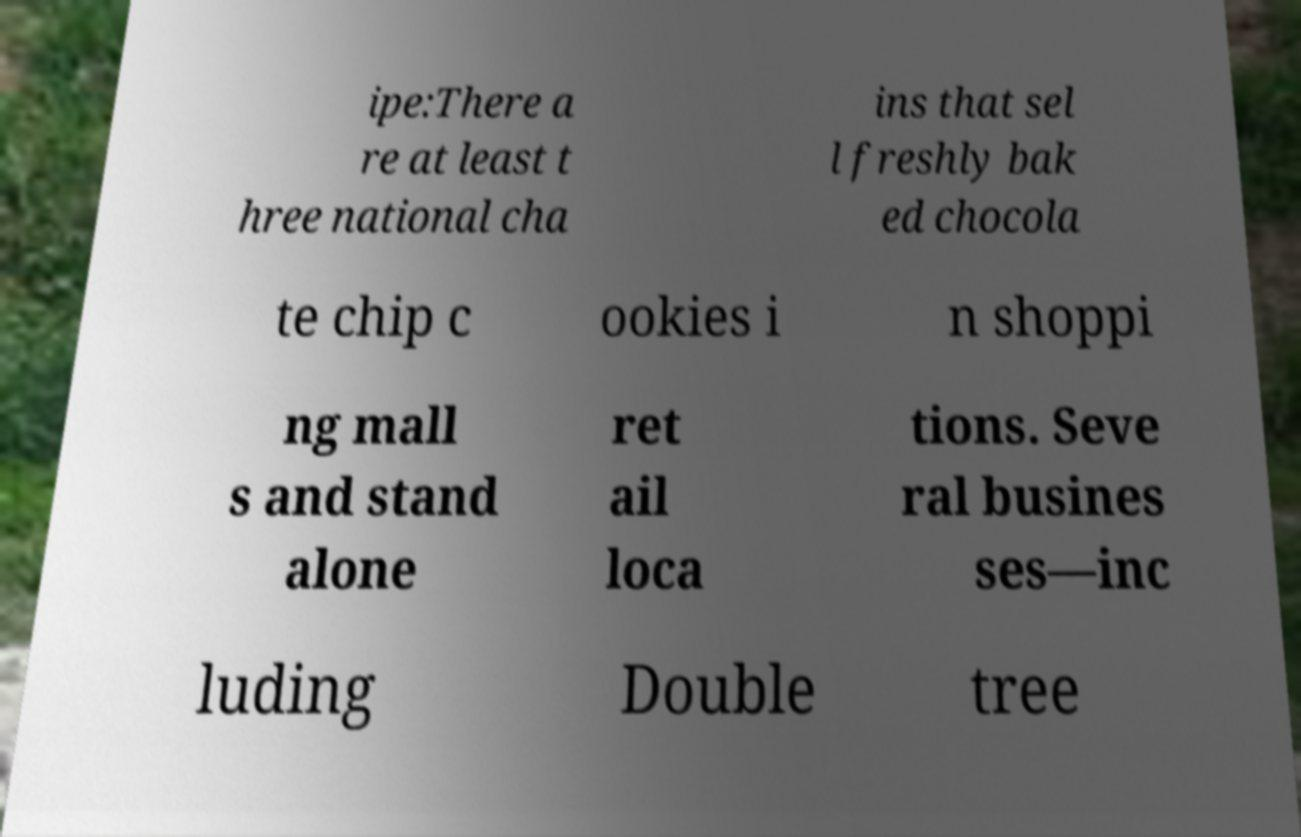What messages or text are displayed in this image? I need them in a readable, typed format. ipe:There a re at least t hree national cha ins that sel l freshly bak ed chocola te chip c ookies i n shoppi ng mall s and stand alone ret ail loca tions. Seve ral busines ses—inc luding Double tree 